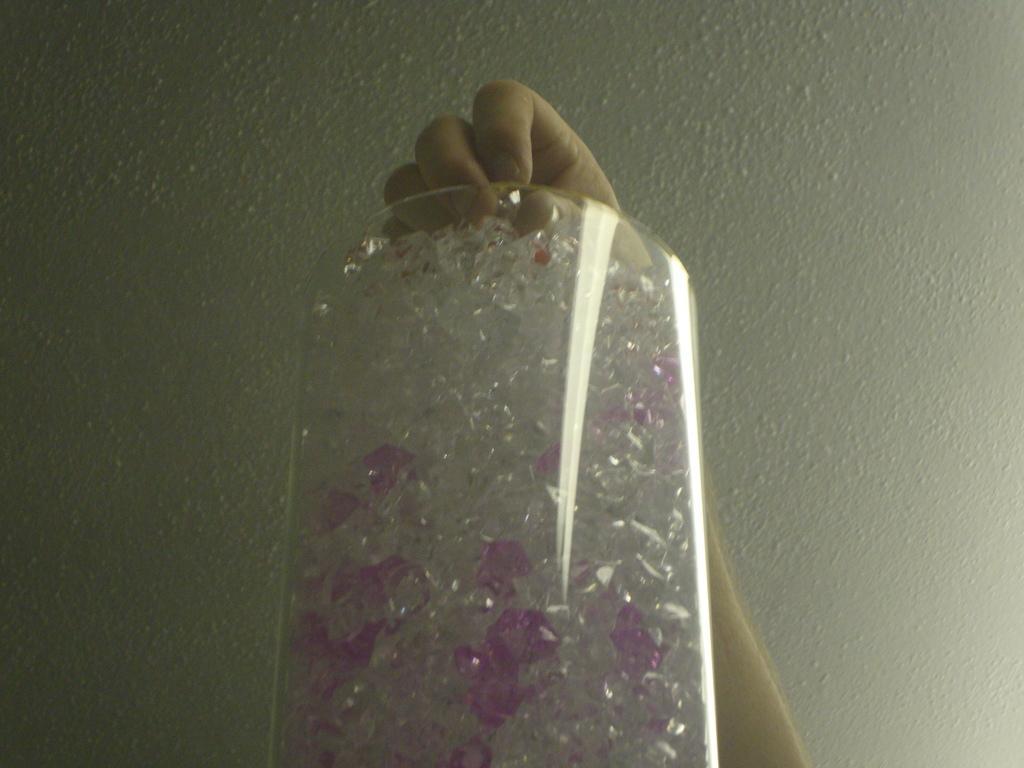Could you give a brief overview of what you see in this image? In this picture we can see only a person hand and the person is holding a transparent material and in the transparent material there are some objects. Behind the hand, there is a wall. 